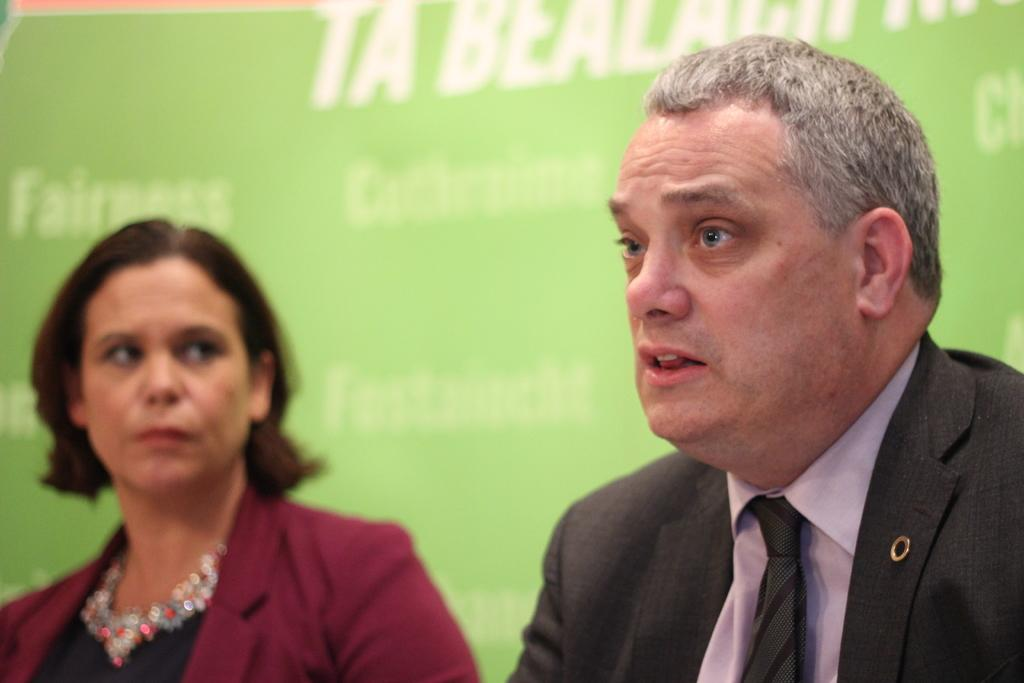How many people are in the image? There are two people in the image. What can be seen hanging or displayed in the image? There is a green color banner in the image. What type of jam is being spread on the banner in the image? There is no jam present in the image, and the banner is not being used for spreading jam. 